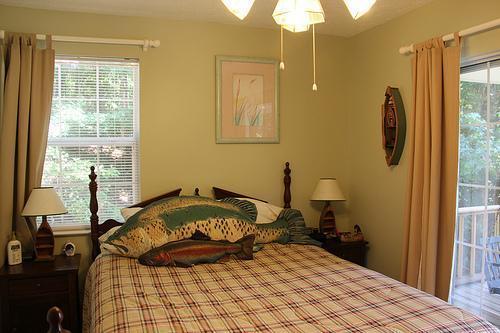How many beds are there?
Give a very brief answer. 1. 